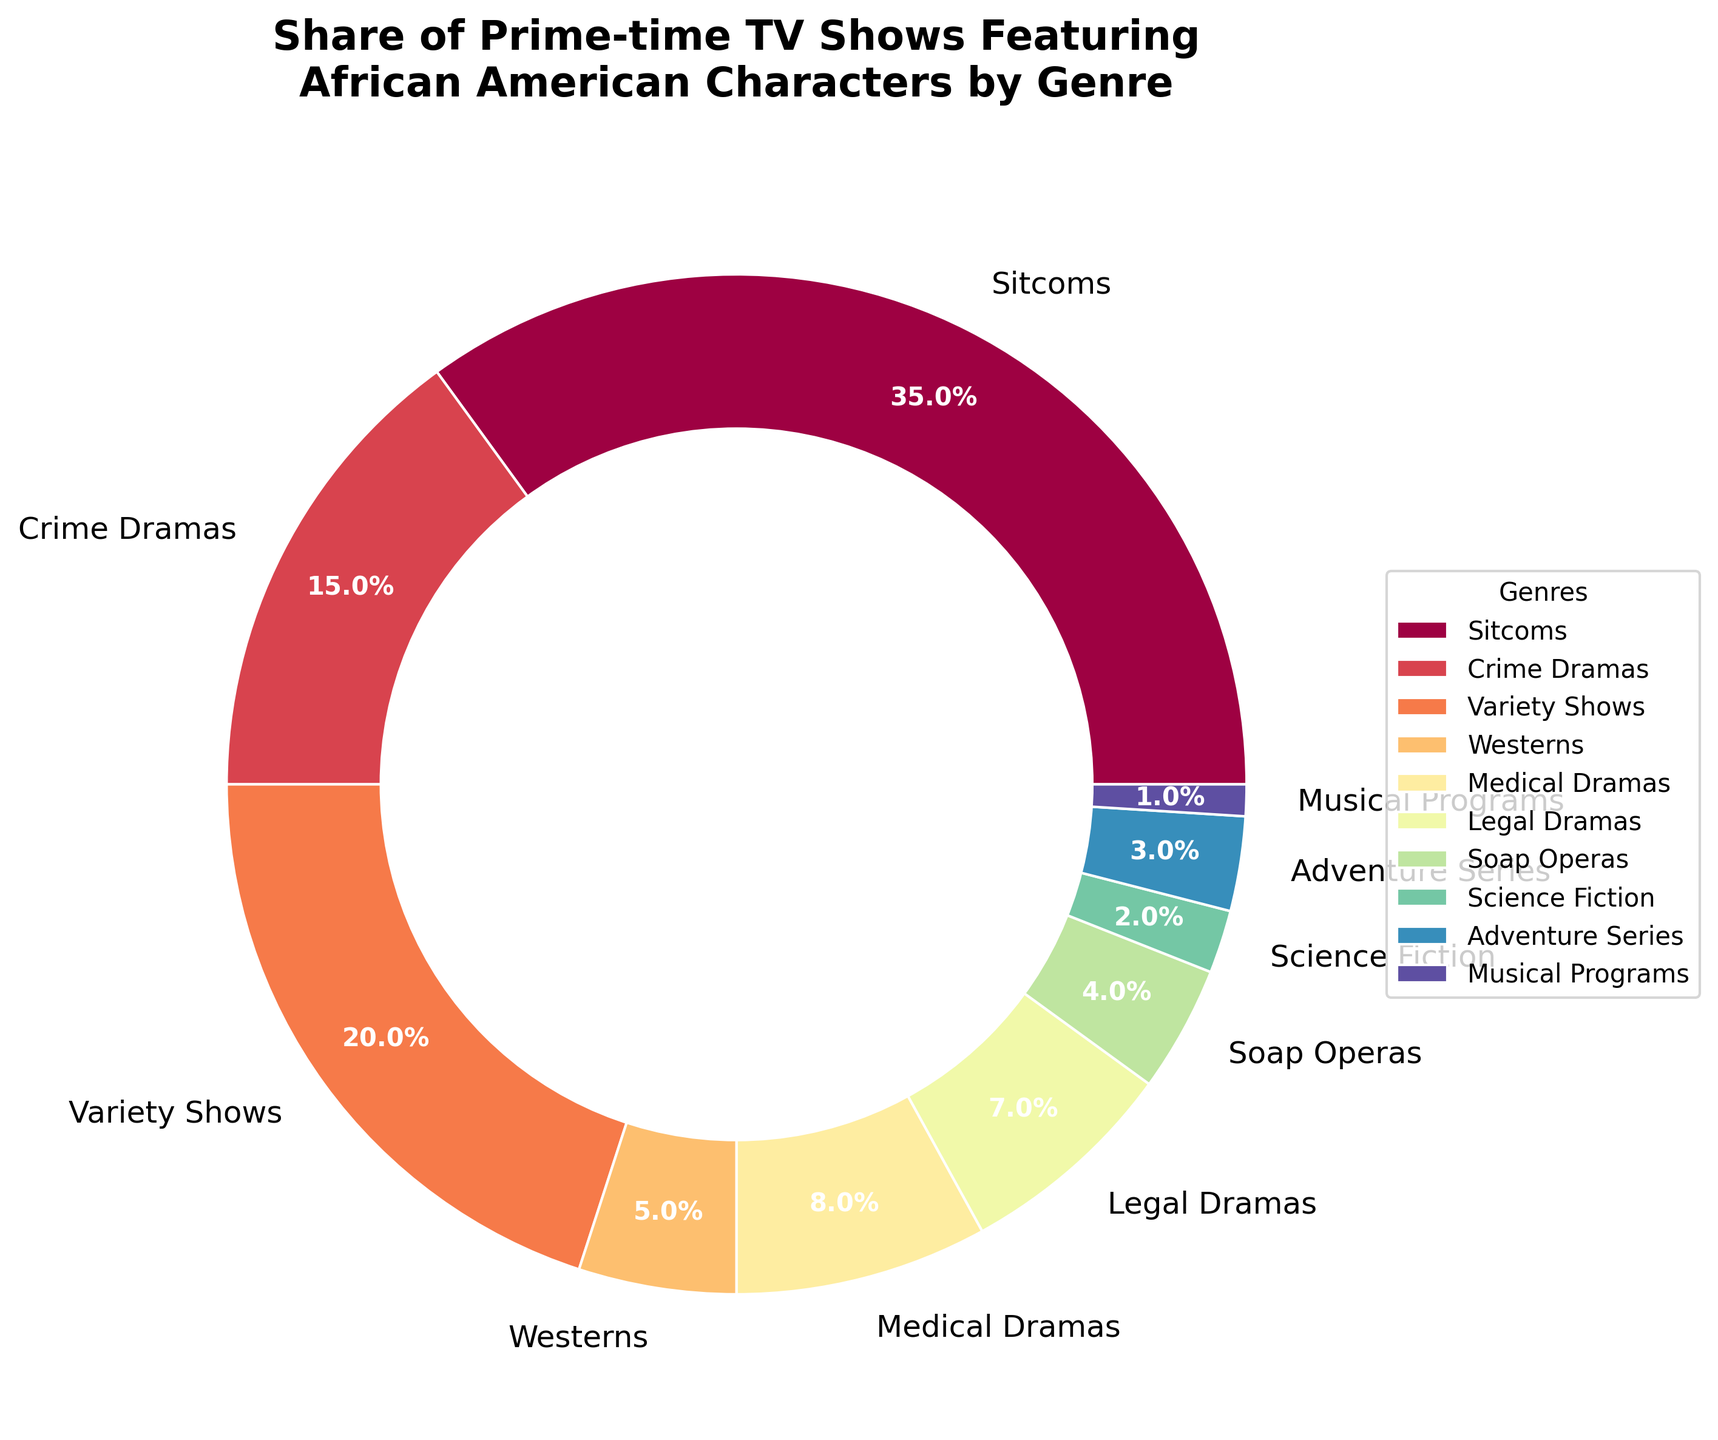What's the largest genre of prime-time TV shows featuring African American characters? To find the largest genre, look at the pie chart and identify the segment with the highest percentage. The Sitcoms segment is the largest at 35%.
Answer: Sitcoms What's the combined percentage of Crime Dramas and Legal Dramas? Add the percentages of Crime Dramas and Legal Dramas. Crime Dramas are 15% and Legal Dramas are 7%. So, 15% + 7% = 22%.
Answer: 22% How many genres have a share of less than 5%? Identify the genres with percentages below 5%: Westerns (5%), Soap Operas (4%), Science Fiction (2%), Adventure Series (3%), and Musical Programs (1%). Count all genres except Westerns, giving 4 genres.
Answer: 4 Which genre has a higher share of African American characters, Medical Dramas or Adventure Series? Compare the percentages for Medical Dramas (8%) and Adventure Series (3%). Medical Dramas have a higher share.
Answer: Medical Dramas What's the difference in percentages between Variety Shows and Soap Operas? Calculate the difference between the percentages of Variety Shows and Soap Operas. Variety Shows are 20% and Soap Operas are 4%. So, 20% - 4% = 16%.
Answer: 16% Are there more prime-time TV shows featuring African American characters in Science Fiction or in Westerns? Compare the percentages of Science Fiction and Westerns. Science Fiction is 2% and Westerns are 5%. Westerns have more.
Answer: Westerns What's the average percentage share of Sitcoms, Crime Dramas, and Variety Shows? Calculate the average by adding the percentages and dividing by the number of genres. (35% Sitcoms + 15% Crime Dramas + 20% Variety Shows) / 3 = 70% / 3 = 23.33%.
Answer: 23.33% Which genre occupies the smallest share of prime-time TV shows featuring African American characters? Identify the genre with the lowest percentage. Musical Programs have the smallest share at 1%.
Answer: Musical Programs What is the sum of the percentages for genres with a share of 5% or higher? Add the percentages for Sitcoms (35%), Crime Dramas (15%), Variety Shows (20%), Westerns (5%), Medical Dramas (8%), and Legal Dramas (7%). 35 + 15 + 20 + 5 + 8 + 7 = 90%.
Answer: 90% 